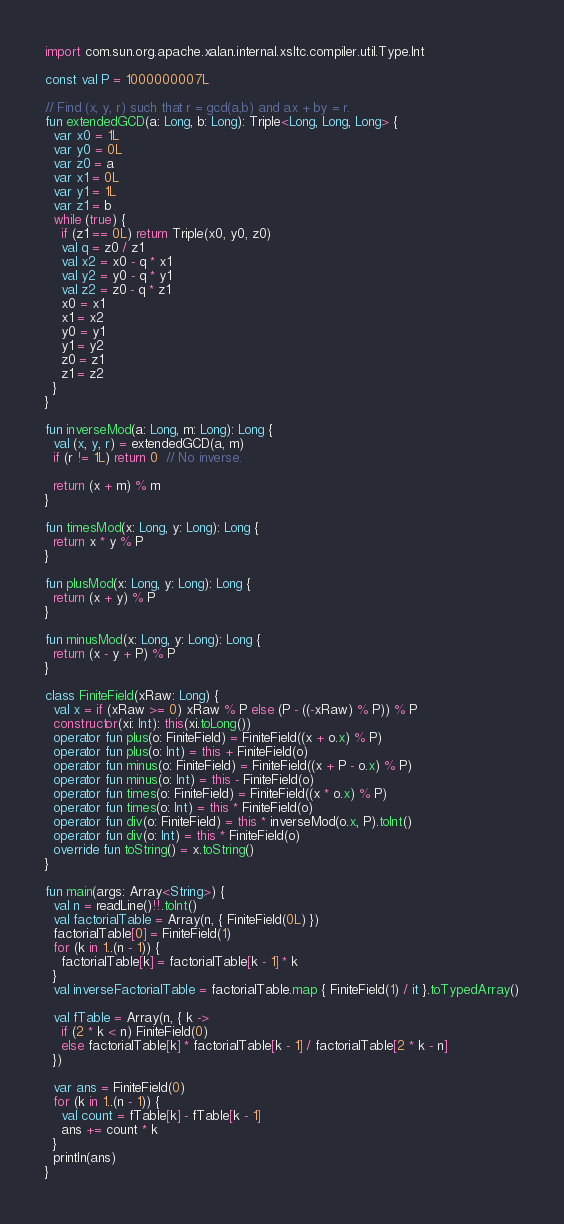Convert code to text. <code><loc_0><loc_0><loc_500><loc_500><_Kotlin_>
import com.sun.org.apache.xalan.internal.xsltc.compiler.util.Type.Int

const val P = 1000000007L

// Find (x, y, r) such that r = gcd(a,b) and ax + by = r.
fun extendedGCD(a: Long, b: Long): Triple<Long, Long, Long> {
  var x0 = 1L
  var y0 = 0L
  var z0 = a
  var x1 = 0L
  var y1 = 1L
  var z1 = b
  while (true) {
    if (z1 == 0L) return Triple(x0, y0, z0)
    val q = z0 / z1
    val x2 = x0 - q * x1
    val y2 = y0 - q * y1
    val z2 = z0 - q * z1
    x0 = x1
    x1 = x2
    y0 = y1
    y1 = y2
    z0 = z1
    z1 = z2
  }
}

fun inverseMod(a: Long, m: Long): Long {
  val (x, y, r) = extendedGCD(a, m)
  if (r != 1L) return 0  // No inverse.

  return (x + m) % m
}

fun timesMod(x: Long, y: Long): Long {
  return x * y % P
}

fun plusMod(x: Long, y: Long): Long {
  return (x + y) % P
}

fun minusMod(x: Long, y: Long): Long {
  return (x - y + P) % P
}

class FiniteField(xRaw: Long) {
  val x = if (xRaw >= 0) xRaw % P else (P - ((-xRaw) % P)) % P
  constructor(xi: Int): this(xi.toLong())
  operator fun plus(o: FiniteField) = FiniteField((x + o.x) % P)
  operator fun plus(o: Int) = this + FiniteField(o)
  operator fun minus(o: FiniteField) = FiniteField((x + P - o.x) % P)
  operator fun minus(o: Int) = this - FiniteField(o)
  operator fun times(o: FiniteField) = FiniteField((x * o.x) % P)
  operator fun times(o: Int) = this * FiniteField(o)
  operator fun div(o: FiniteField) = this * inverseMod(o.x, P).toInt()
  operator fun div(o: Int) = this * FiniteField(o)
  override fun toString() = x.toString()
}

fun main(args: Array<String>) {
  val n = readLine()!!.toInt()
  val factorialTable = Array(n, { FiniteField(0L) })
  factorialTable[0] = FiniteField(1)
  for (k in 1..(n - 1)) {
    factorialTable[k] = factorialTable[k - 1] * k
  }
  val inverseFactorialTable = factorialTable.map { FiniteField(1) / it }.toTypedArray()

  val fTable = Array(n, { k ->
    if (2 * k < n) FiniteField(0)
    else factorialTable[k] * factorialTable[k - 1] / factorialTable[2 * k - n]
  })

  var ans = FiniteField(0)
  for (k in 1..(n - 1)) {
    val count = fTable[k] - fTable[k - 1]
    ans += count * k
  }
  println(ans)
}</code> 